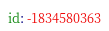Convert code to text. <code><loc_0><loc_0><loc_500><loc_500><_YAML_>id: -1834580363
</code> 